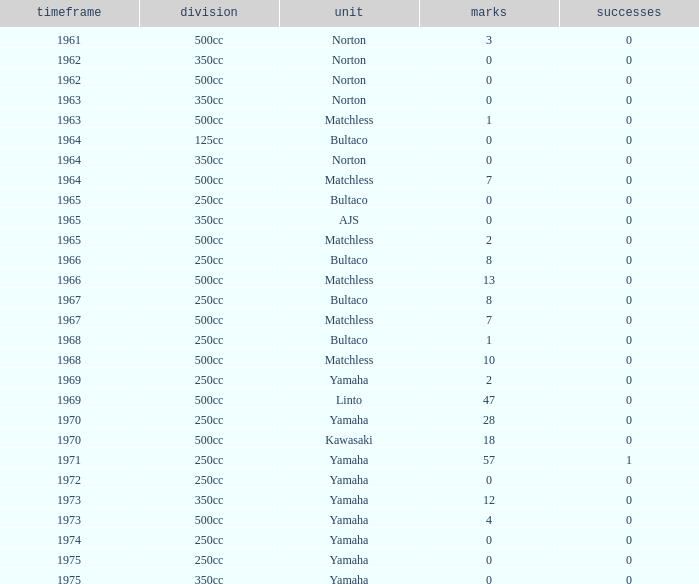What is the sum of all points in 1975 with 0 wins? None. 